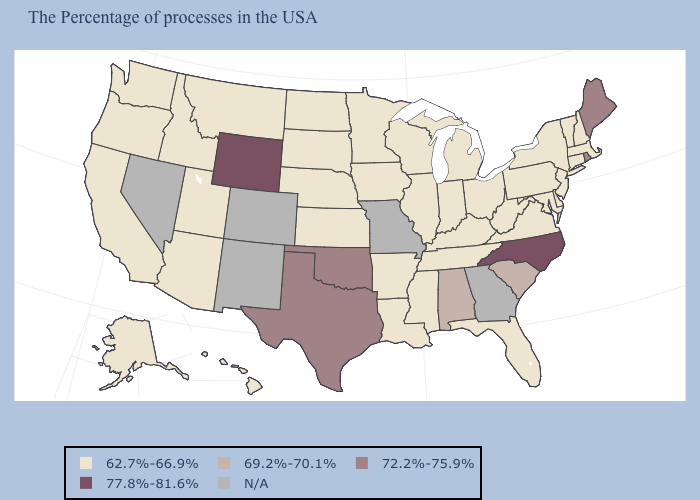Name the states that have a value in the range 69.2%-70.1%?
Short answer required. South Carolina, Alabama. What is the lowest value in states that border Rhode Island?
Give a very brief answer. 62.7%-66.9%. Is the legend a continuous bar?
Short answer required. No. Name the states that have a value in the range 72.2%-75.9%?
Short answer required. Maine, Rhode Island, Oklahoma, Texas. Which states have the highest value in the USA?
Answer briefly. North Carolina, Wyoming. Which states hav the highest value in the Northeast?
Be succinct. Maine, Rhode Island. Does Mississippi have the lowest value in the USA?
Give a very brief answer. Yes. Among the states that border South Carolina , which have the lowest value?
Answer briefly. North Carolina. What is the value of Ohio?
Write a very short answer. 62.7%-66.9%. Which states hav the highest value in the South?
Write a very short answer. North Carolina. Does the first symbol in the legend represent the smallest category?
Keep it brief. Yes. What is the value of Connecticut?
Keep it brief. 62.7%-66.9%. 